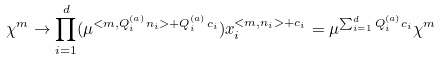Convert formula to latex. <formula><loc_0><loc_0><loc_500><loc_500>\chi ^ { m } \rightarrow \prod _ { i = 1 } ^ { d } ( \mu ^ { < m , Q _ { i } ^ { ( a ) } n _ { i } > + Q _ { i } ^ { ( a ) } c _ { i } } ) x _ { i } ^ { < m , n _ { i } > + c _ { i } } = \mu ^ { \sum _ { i = 1 } ^ { d } Q _ { i } ^ { ( a ) } c _ { i } } \chi ^ { m }</formula> 